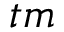Convert formula to latex. <formula><loc_0><loc_0><loc_500><loc_500>t m</formula> 